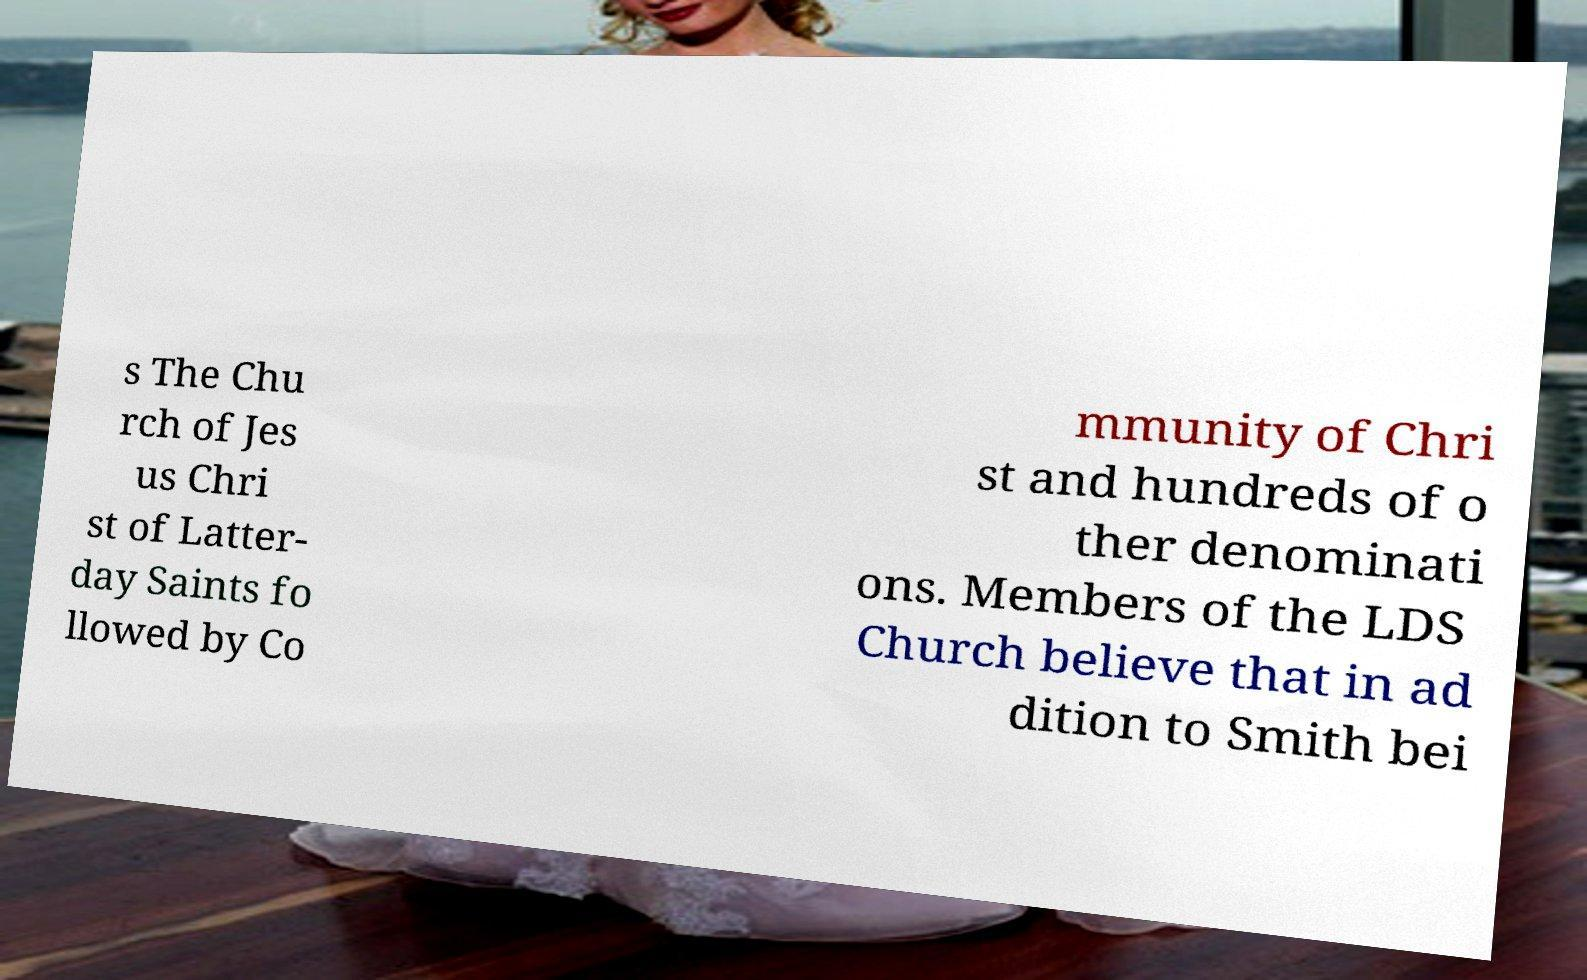What messages or text are displayed in this image? I need them in a readable, typed format. s The Chu rch of Jes us Chri st of Latter- day Saints fo llowed by Co mmunity of Chri st and hundreds of o ther denominati ons. Members of the LDS Church believe that in ad dition to Smith bei 